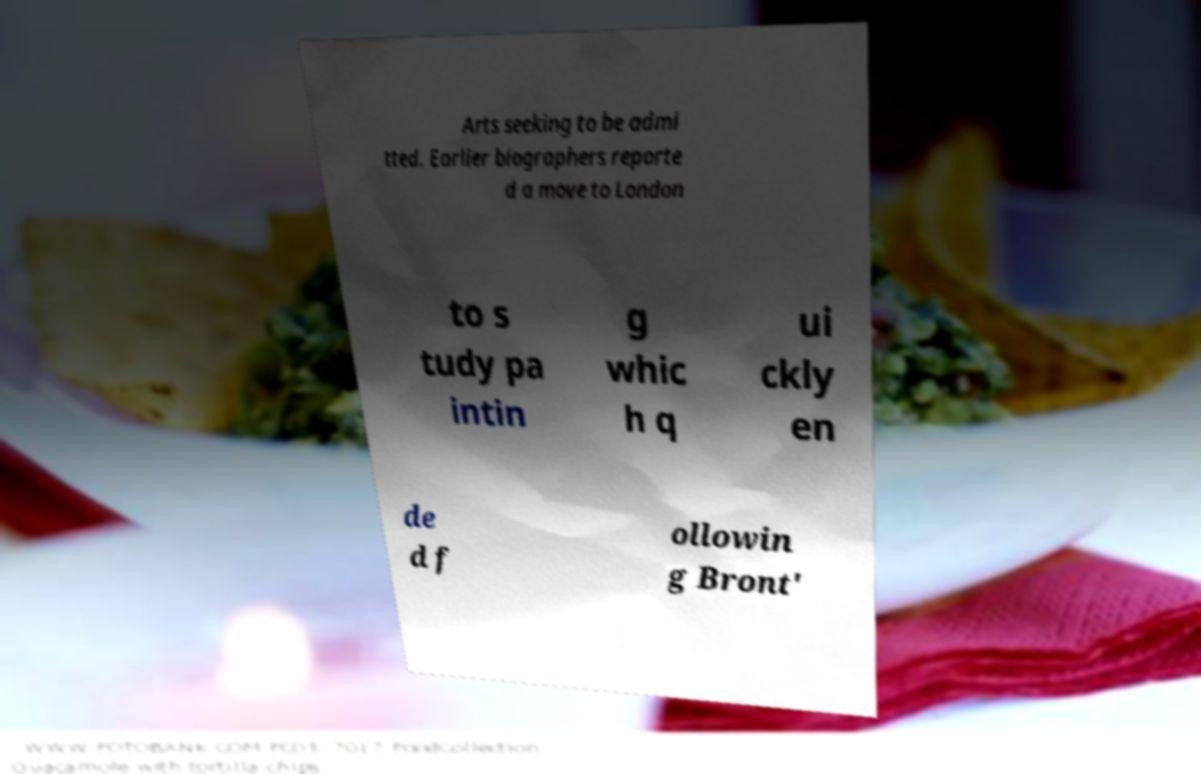Can you read and provide the text displayed in the image?This photo seems to have some interesting text. Can you extract and type it out for me? Arts seeking to be admi tted. Earlier biographers reporte d a move to London to s tudy pa intin g whic h q ui ckly en de d f ollowin g Bront' 